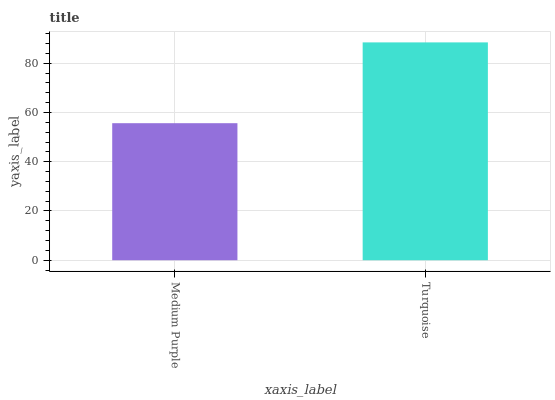Is Medium Purple the minimum?
Answer yes or no. Yes. Is Turquoise the maximum?
Answer yes or no. Yes. Is Turquoise the minimum?
Answer yes or no. No. Is Turquoise greater than Medium Purple?
Answer yes or no. Yes. Is Medium Purple less than Turquoise?
Answer yes or no. Yes. Is Medium Purple greater than Turquoise?
Answer yes or no. No. Is Turquoise less than Medium Purple?
Answer yes or no. No. Is Turquoise the high median?
Answer yes or no. Yes. Is Medium Purple the low median?
Answer yes or no. Yes. Is Medium Purple the high median?
Answer yes or no. No. Is Turquoise the low median?
Answer yes or no. No. 